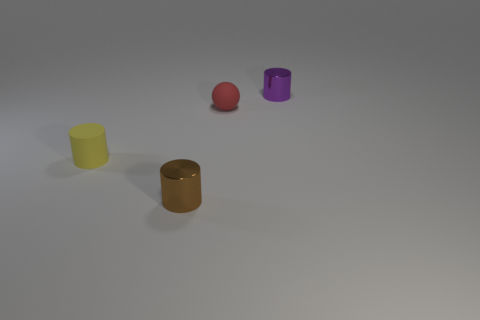Add 4 yellow cylinders. How many objects exist? 8 Subtract all cylinders. How many objects are left? 1 Add 3 yellow objects. How many yellow objects are left? 4 Add 2 purple things. How many purple things exist? 3 Subtract 0 green cylinders. How many objects are left? 4 Subtract all small cyan metallic cylinders. Subtract all shiny things. How many objects are left? 2 